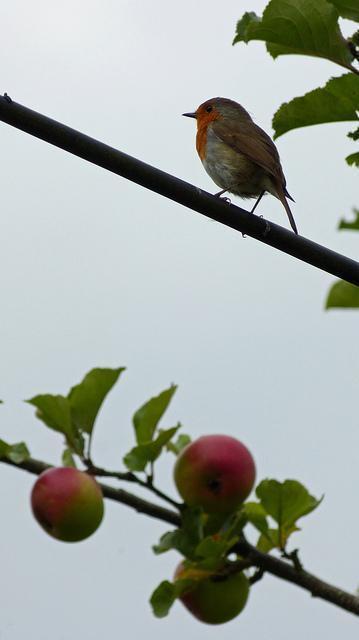How many birds are hanging upside down?
Choose the correct response, then elucidate: 'Answer: answer
Rationale: rationale.'
Options: Four, none, three, two. Answer: none.
Rationale: The only bird pictured is standing on the branch, right side up. 